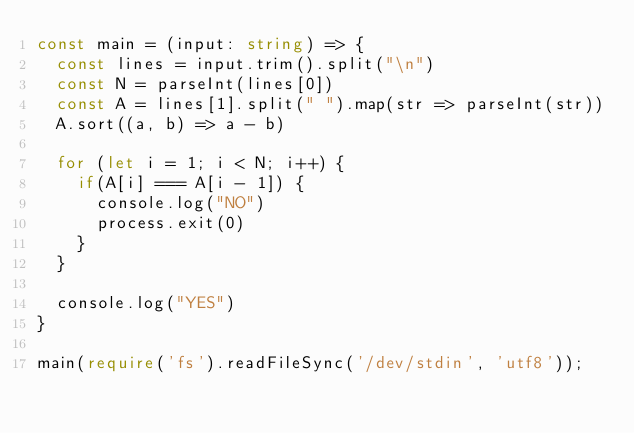<code> <loc_0><loc_0><loc_500><loc_500><_TypeScript_>const main = (input: string) => {
  const lines = input.trim().split("\n")
  const N = parseInt(lines[0])
  const A = lines[1].split(" ").map(str => parseInt(str))
  A.sort((a, b) => a - b)

  for (let i = 1; i < N; i++) {
    if(A[i] === A[i - 1]) {
      console.log("NO")
      process.exit(0)
    }
  }

  console.log("YES")  
}

main(require('fs').readFileSync('/dev/stdin', 'utf8'));
</code> 